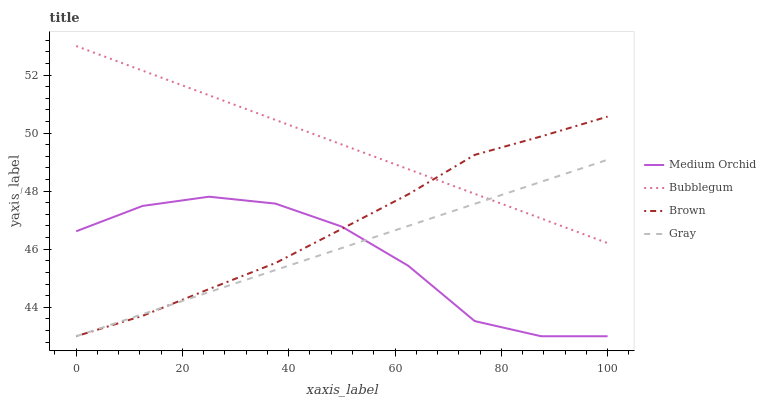Does Bubblegum have the minimum area under the curve?
Answer yes or no. No. Does Medium Orchid have the maximum area under the curve?
Answer yes or no. No. Is Bubblegum the smoothest?
Answer yes or no. No. Is Bubblegum the roughest?
Answer yes or no. No. Does Bubblegum have the lowest value?
Answer yes or no. No. Does Medium Orchid have the highest value?
Answer yes or no. No. Is Medium Orchid less than Bubblegum?
Answer yes or no. Yes. Is Bubblegum greater than Medium Orchid?
Answer yes or no. Yes. Does Medium Orchid intersect Bubblegum?
Answer yes or no. No. 